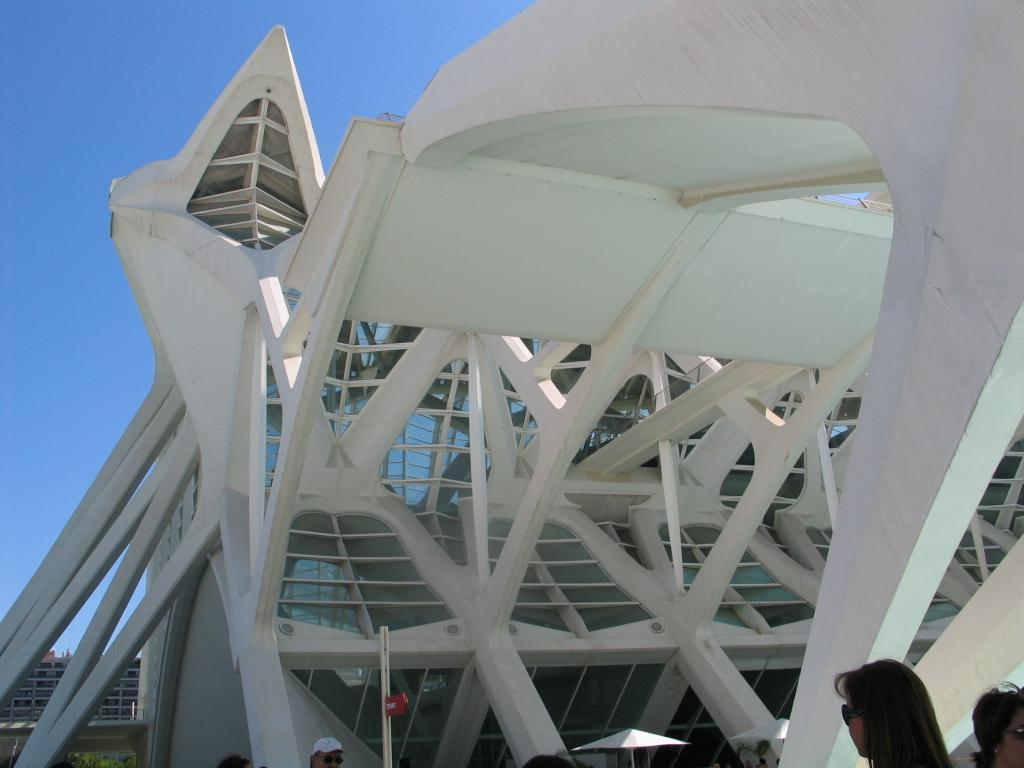What type of structures can be seen in the image? There are buildings in the image. What else can be seen in the image besides buildings? There are poles and parasols in the image. Are there any people present in the image? Yes, there are persons in the image. What can be seen in the background of the image? The sky is visible in the background of the image. What day of the week is depicted in the image? The day of the week is not depicted in the image; it only shows buildings, poles, parasols, persons, and the sky. Are there any bikes or a cemetery present in the image? No, there are no bikes or a cemetery present in the image. 